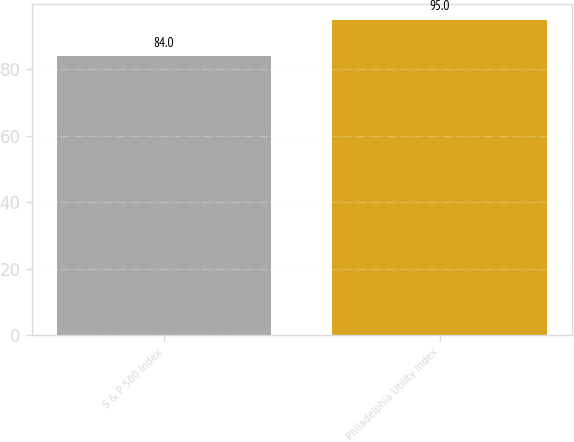<chart> <loc_0><loc_0><loc_500><loc_500><bar_chart><fcel>S & P 500 Index<fcel>Philadelphia Utility Index<nl><fcel>84<fcel>95<nl></chart> 